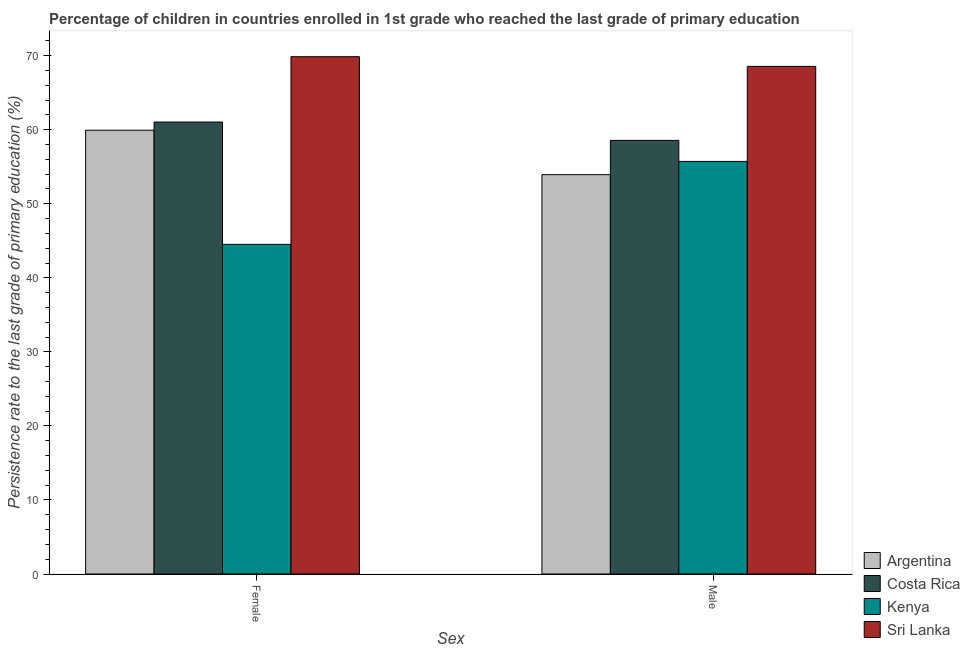How many different coloured bars are there?
Keep it short and to the point. 4. Are the number of bars per tick equal to the number of legend labels?
Provide a short and direct response. Yes. How many bars are there on the 2nd tick from the left?
Offer a very short reply. 4. What is the label of the 2nd group of bars from the left?
Provide a succinct answer. Male. What is the persistence rate of male students in Kenya?
Offer a terse response. 55.72. Across all countries, what is the maximum persistence rate of female students?
Ensure brevity in your answer.  69.87. Across all countries, what is the minimum persistence rate of female students?
Make the answer very short. 44.52. In which country was the persistence rate of male students maximum?
Provide a succinct answer. Sri Lanka. In which country was the persistence rate of female students minimum?
Your answer should be compact. Kenya. What is the total persistence rate of male students in the graph?
Provide a succinct answer. 236.77. What is the difference between the persistence rate of male students in Argentina and that in Kenya?
Your response must be concise. -1.79. What is the difference between the persistence rate of male students in Costa Rica and the persistence rate of female students in Kenya?
Provide a succinct answer. 14.04. What is the average persistence rate of male students per country?
Your answer should be very brief. 59.19. What is the difference between the persistence rate of female students and persistence rate of male students in Kenya?
Offer a terse response. -11.2. In how many countries, is the persistence rate of male students greater than 20 %?
Keep it short and to the point. 4. What is the ratio of the persistence rate of male students in Costa Rica to that in Kenya?
Keep it short and to the point. 1.05. What does the 3rd bar from the left in Female represents?
Give a very brief answer. Kenya. What does the 2nd bar from the right in Male represents?
Provide a succinct answer. Kenya. How many bars are there?
Offer a terse response. 8. Are all the bars in the graph horizontal?
Your answer should be compact. No. How many countries are there in the graph?
Your answer should be very brief. 4. Are the values on the major ticks of Y-axis written in scientific E-notation?
Offer a very short reply. No. How are the legend labels stacked?
Keep it short and to the point. Vertical. What is the title of the graph?
Make the answer very short. Percentage of children in countries enrolled in 1st grade who reached the last grade of primary education. Does "Kenya" appear as one of the legend labels in the graph?
Your answer should be very brief. Yes. What is the label or title of the X-axis?
Offer a very short reply. Sex. What is the label or title of the Y-axis?
Keep it short and to the point. Persistence rate to the last grade of primary education (%). What is the Persistence rate to the last grade of primary education (%) in Argentina in Female?
Provide a succinct answer. 59.94. What is the Persistence rate to the last grade of primary education (%) in Costa Rica in Female?
Your response must be concise. 61.04. What is the Persistence rate to the last grade of primary education (%) in Kenya in Female?
Your answer should be very brief. 44.52. What is the Persistence rate to the last grade of primary education (%) of Sri Lanka in Female?
Provide a succinct answer. 69.87. What is the Persistence rate to the last grade of primary education (%) of Argentina in Male?
Provide a short and direct response. 53.93. What is the Persistence rate to the last grade of primary education (%) in Costa Rica in Male?
Offer a terse response. 58.56. What is the Persistence rate to the last grade of primary education (%) of Kenya in Male?
Your answer should be compact. 55.72. What is the Persistence rate to the last grade of primary education (%) of Sri Lanka in Male?
Provide a succinct answer. 68.56. Across all Sex, what is the maximum Persistence rate to the last grade of primary education (%) of Argentina?
Make the answer very short. 59.94. Across all Sex, what is the maximum Persistence rate to the last grade of primary education (%) in Costa Rica?
Provide a succinct answer. 61.04. Across all Sex, what is the maximum Persistence rate to the last grade of primary education (%) of Kenya?
Offer a very short reply. 55.72. Across all Sex, what is the maximum Persistence rate to the last grade of primary education (%) of Sri Lanka?
Offer a terse response. 69.87. Across all Sex, what is the minimum Persistence rate to the last grade of primary education (%) in Argentina?
Your response must be concise. 53.93. Across all Sex, what is the minimum Persistence rate to the last grade of primary education (%) in Costa Rica?
Provide a succinct answer. 58.56. Across all Sex, what is the minimum Persistence rate to the last grade of primary education (%) of Kenya?
Provide a short and direct response. 44.52. Across all Sex, what is the minimum Persistence rate to the last grade of primary education (%) of Sri Lanka?
Make the answer very short. 68.56. What is the total Persistence rate to the last grade of primary education (%) of Argentina in the graph?
Keep it short and to the point. 113.87. What is the total Persistence rate to the last grade of primary education (%) in Costa Rica in the graph?
Your answer should be very brief. 119.6. What is the total Persistence rate to the last grade of primary education (%) of Kenya in the graph?
Your answer should be very brief. 100.24. What is the total Persistence rate to the last grade of primary education (%) of Sri Lanka in the graph?
Make the answer very short. 138.42. What is the difference between the Persistence rate to the last grade of primary education (%) of Argentina in Female and that in Male?
Your answer should be compact. 6.01. What is the difference between the Persistence rate to the last grade of primary education (%) of Costa Rica in Female and that in Male?
Keep it short and to the point. 2.48. What is the difference between the Persistence rate to the last grade of primary education (%) in Kenya in Female and that in Male?
Your answer should be compact. -11.2. What is the difference between the Persistence rate to the last grade of primary education (%) in Sri Lanka in Female and that in Male?
Make the answer very short. 1.31. What is the difference between the Persistence rate to the last grade of primary education (%) of Argentina in Female and the Persistence rate to the last grade of primary education (%) of Costa Rica in Male?
Your answer should be very brief. 1.38. What is the difference between the Persistence rate to the last grade of primary education (%) in Argentina in Female and the Persistence rate to the last grade of primary education (%) in Kenya in Male?
Ensure brevity in your answer.  4.22. What is the difference between the Persistence rate to the last grade of primary education (%) in Argentina in Female and the Persistence rate to the last grade of primary education (%) in Sri Lanka in Male?
Ensure brevity in your answer.  -8.62. What is the difference between the Persistence rate to the last grade of primary education (%) of Costa Rica in Female and the Persistence rate to the last grade of primary education (%) of Kenya in Male?
Ensure brevity in your answer.  5.32. What is the difference between the Persistence rate to the last grade of primary education (%) of Costa Rica in Female and the Persistence rate to the last grade of primary education (%) of Sri Lanka in Male?
Give a very brief answer. -7.52. What is the difference between the Persistence rate to the last grade of primary education (%) in Kenya in Female and the Persistence rate to the last grade of primary education (%) in Sri Lanka in Male?
Make the answer very short. -24.03. What is the average Persistence rate to the last grade of primary education (%) of Argentina per Sex?
Provide a succinct answer. 56.94. What is the average Persistence rate to the last grade of primary education (%) of Costa Rica per Sex?
Offer a very short reply. 59.8. What is the average Persistence rate to the last grade of primary education (%) of Kenya per Sex?
Your response must be concise. 50.12. What is the average Persistence rate to the last grade of primary education (%) of Sri Lanka per Sex?
Offer a very short reply. 69.21. What is the difference between the Persistence rate to the last grade of primary education (%) of Argentina and Persistence rate to the last grade of primary education (%) of Costa Rica in Female?
Your answer should be compact. -1.1. What is the difference between the Persistence rate to the last grade of primary education (%) of Argentina and Persistence rate to the last grade of primary education (%) of Kenya in Female?
Offer a terse response. 15.42. What is the difference between the Persistence rate to the last grade of primary education (%) in Argentina and Persistence rate to the last grade of primary education (%) in Sri Lanka in Female?
Your answer should be compact. -9.93. What is the difference between the Persistence rate to the last grade of primary education (%) in Costa Rica and Persistence rate to the last grade of primary education (%) in Kenya in Female?
Keep it short and to the point. 16.52. What is the difference between the Persistence rate to the last grade of primary education (%) in Costa Rica and Persistence rate to the last grade of primary education (%) in Sri Lanka in Female?
Your answer should be compact. -8.83. What is the difference between the Persistence rate to the last grade of primary education (%) of Kenya and Persistence rate to the last grade of primary education (%) of Sri Lanka in Female?
Offer a very short reply. -25.34. What is the difference between the Persistence rate to the last grade of primary education (%) of Argentina and Persistence rate to the last grade of primary education (%) of Costa Rica in Male?
Offer a very short reply. -4.63. What is the difference between the Persistence rate to the last grade of primary education (%) in Argentina and Persistence rate to the last grade of primary education (%) in Kenya in Male?
Make the answer very short. -1.79. What is the difference between the Persistence rate to the last grade of primary education (%) of Argentina and Persistence rate to the last grade of primary education (%) of Sri Lanka in Male?
Provide a succinct answer. -14.62. What is the difference between the Persistence rate to the last grade of primary education (%) of Costa Rica and Persistence rate to the last grade of primary education (%) of Kenya in Male?
Keep it short and to the point. 2.84. What is the difference between the Persistence rate to the last grade of primary education (%) of Costa Rica and Persistence rate to the last grade of primary education (%) of Sri Lanka in Male?
Your response must be concise. -9.99. What is the difference between the Persistence rate to the last grade of primary education (%) in Kenya and Persistence rate to the last grade of primary education (%) in Sri Lanka in Male?
Offer a terse response. -12.83. What is the ratio of the Persistence rate to the last grade of primary education (%) in Argentina in Female to that in Male?
Provide a succinct answer. 1.11. What is the ratio of the Persistence rate to the last grade of primary education (%) in Costa Rica in Female to that in Male?
Your response must be concise. 1.04. What is the ratio of the Persistence rate to the last grade of primary education (%) of Kenya in Female to that in Male?
Provide a short and direct response. 0.8. What is the ratio of the Persistence rate to the last grade of primary education (%) in Sri Lanka in Female to that in Male?
Offer a terse response. 1.02. What is the difference between the highest and the second highest Persistence rate to the last grade of primary education (%) of Argentina?
Provide a short and direct response. 6.01. What is the difference between the highest and the second highest Persistence rate to the last grade of primary education (%) of Costa Rica?
Keep it short and to the point. 2.48. What is the difference between the highest and the second highest Persistence rate to the last grade of primary education (%) of Kenya?
Your response must be concise. 11.2. What is the difference between the highest and the second highest Persistence rate to the last grade of primary education (%) in Sri Lanka?
Keep it short and to the point. 1.31. What is the difference between the highest and the lowest Persistence rate to the last grade of primary education (%) of Argentina?
Keep it short and to the point. 6.01. What is the difference between the highest and the lowest Persistence rate to the last grade of primary education (%) in Costa Rica?
Provide a succinct answer. 2.48. What is the difference between the highest and the lowest Persistence rate to the last grade of primary education (%) of Kenya?
Your answer should be very brief. 11.2. What is the difference between the highest and the lowest Persistence rate to the last grade of primary education (%) of Sri Lanka?
Keep it short and to the point. 1.31. 